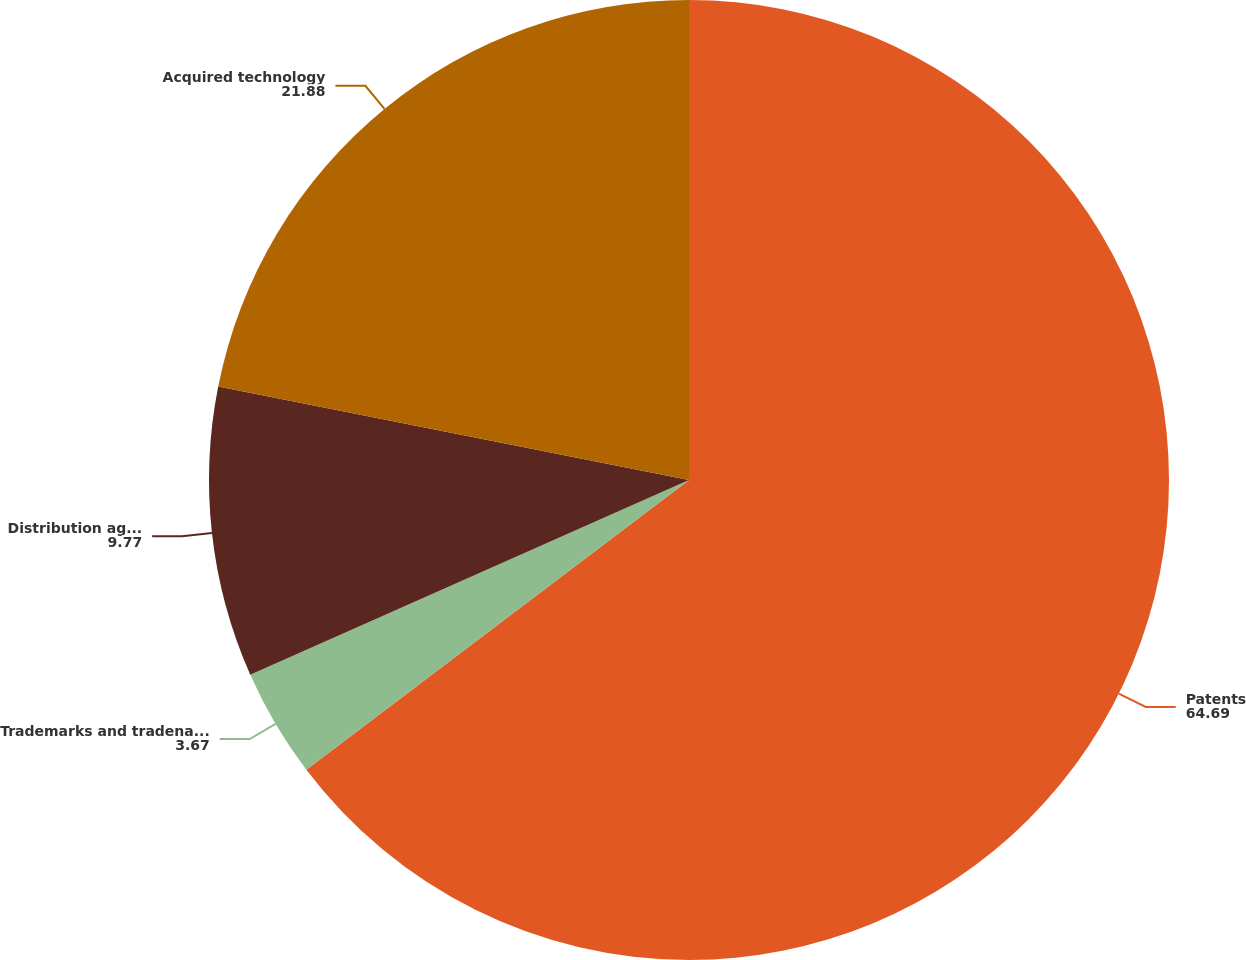<chart> <loc_0><loc_0><loc_500><loc_500><pie_chart><fcel>Patents<fcel>Trademarks and tradenames<fcel>Distribution agreements<fcel>Acquired technology<nl><fcel>64.69%<fcel>3.67%<fcel>9.77%<fcel>21.88%<nl></chart> 